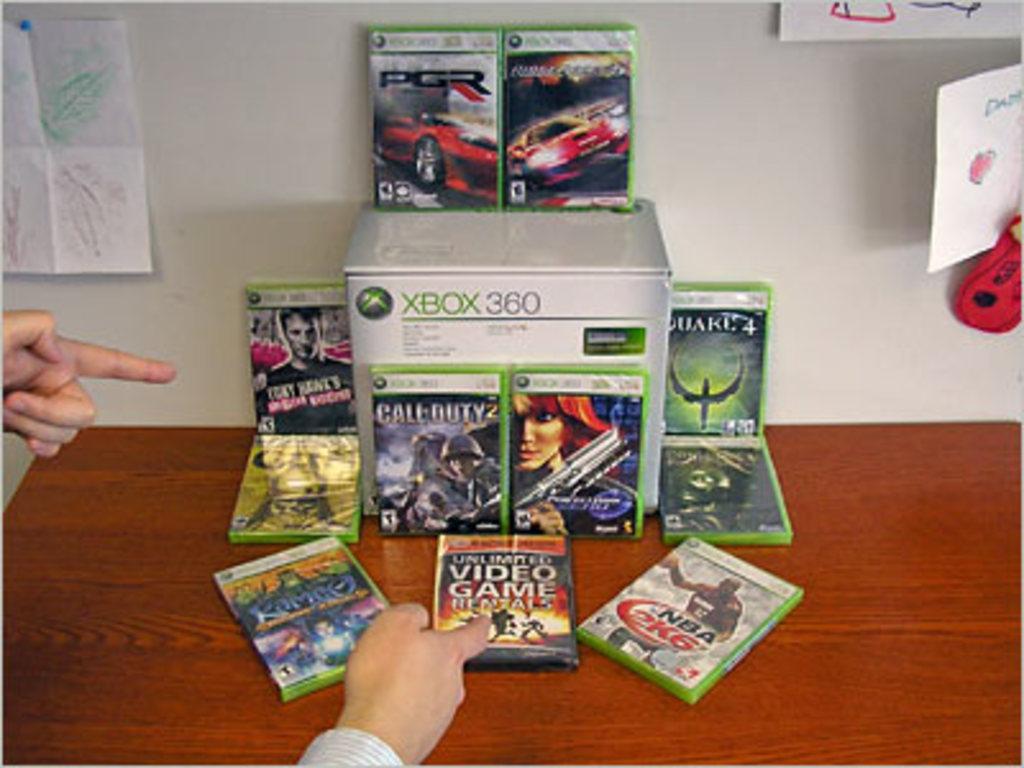In one or two sentences, can you explain what this image depicts? In this picture I can see there are few compact discs placed on the wooden table, there is a carton box placed on the table and the wall in the backdrop has papers pasted on it. There is a person pointing at the CD's. 